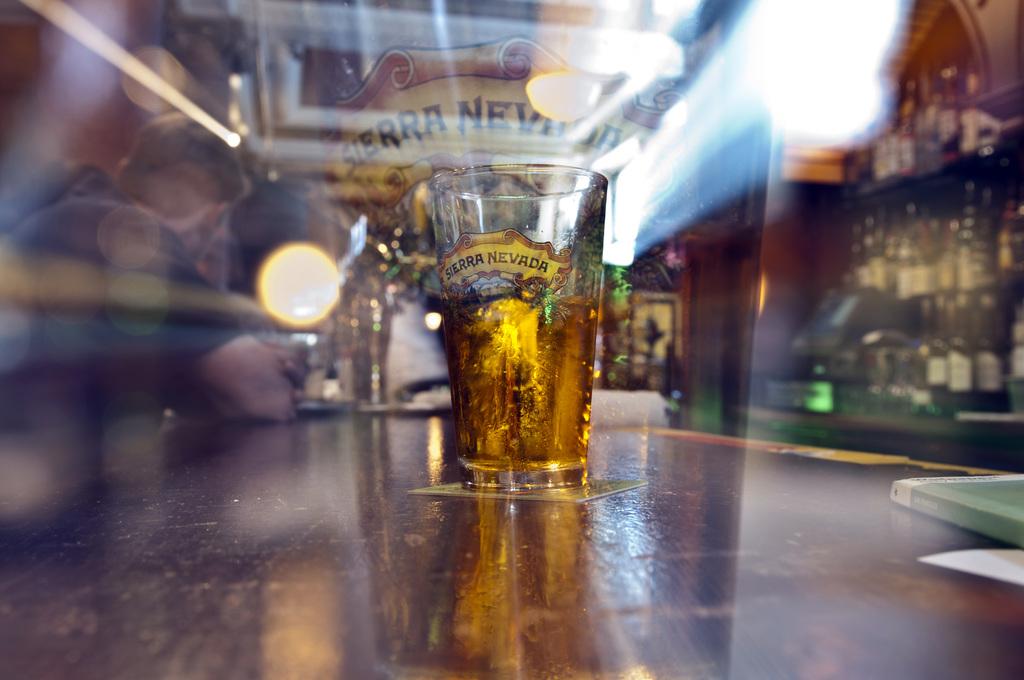What is the brand name featured on this glass?
Make the answer very short. Sierra nevada. 